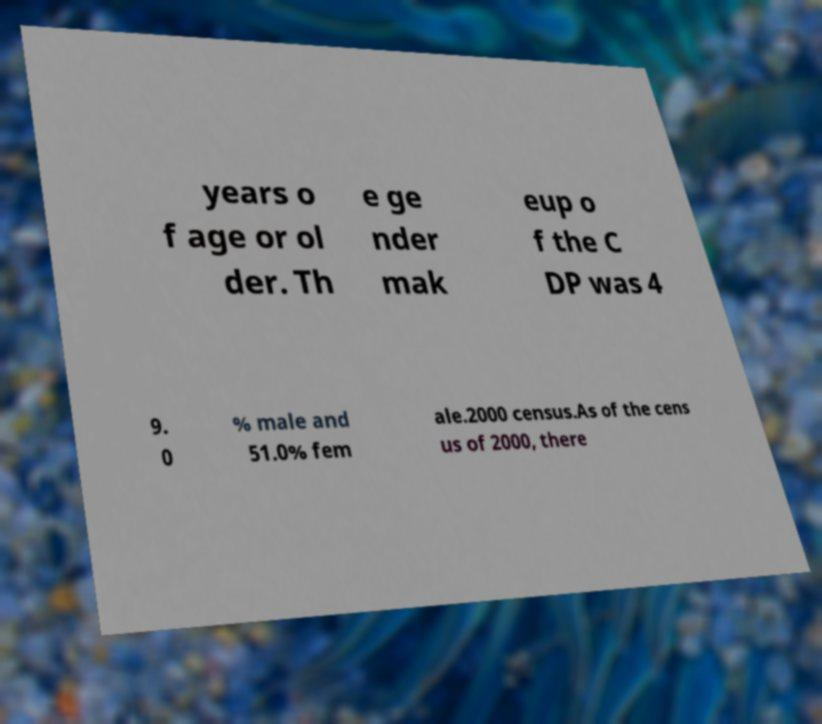For documentation purposes, I need the text within this image transcribed. Could you provide that? years o f age or ol der. Th e ge nder mak eup o f the C DP was 4 9. 0 % male and 51.0% fem ale.2000 census.As of the cens us of 2000, there 